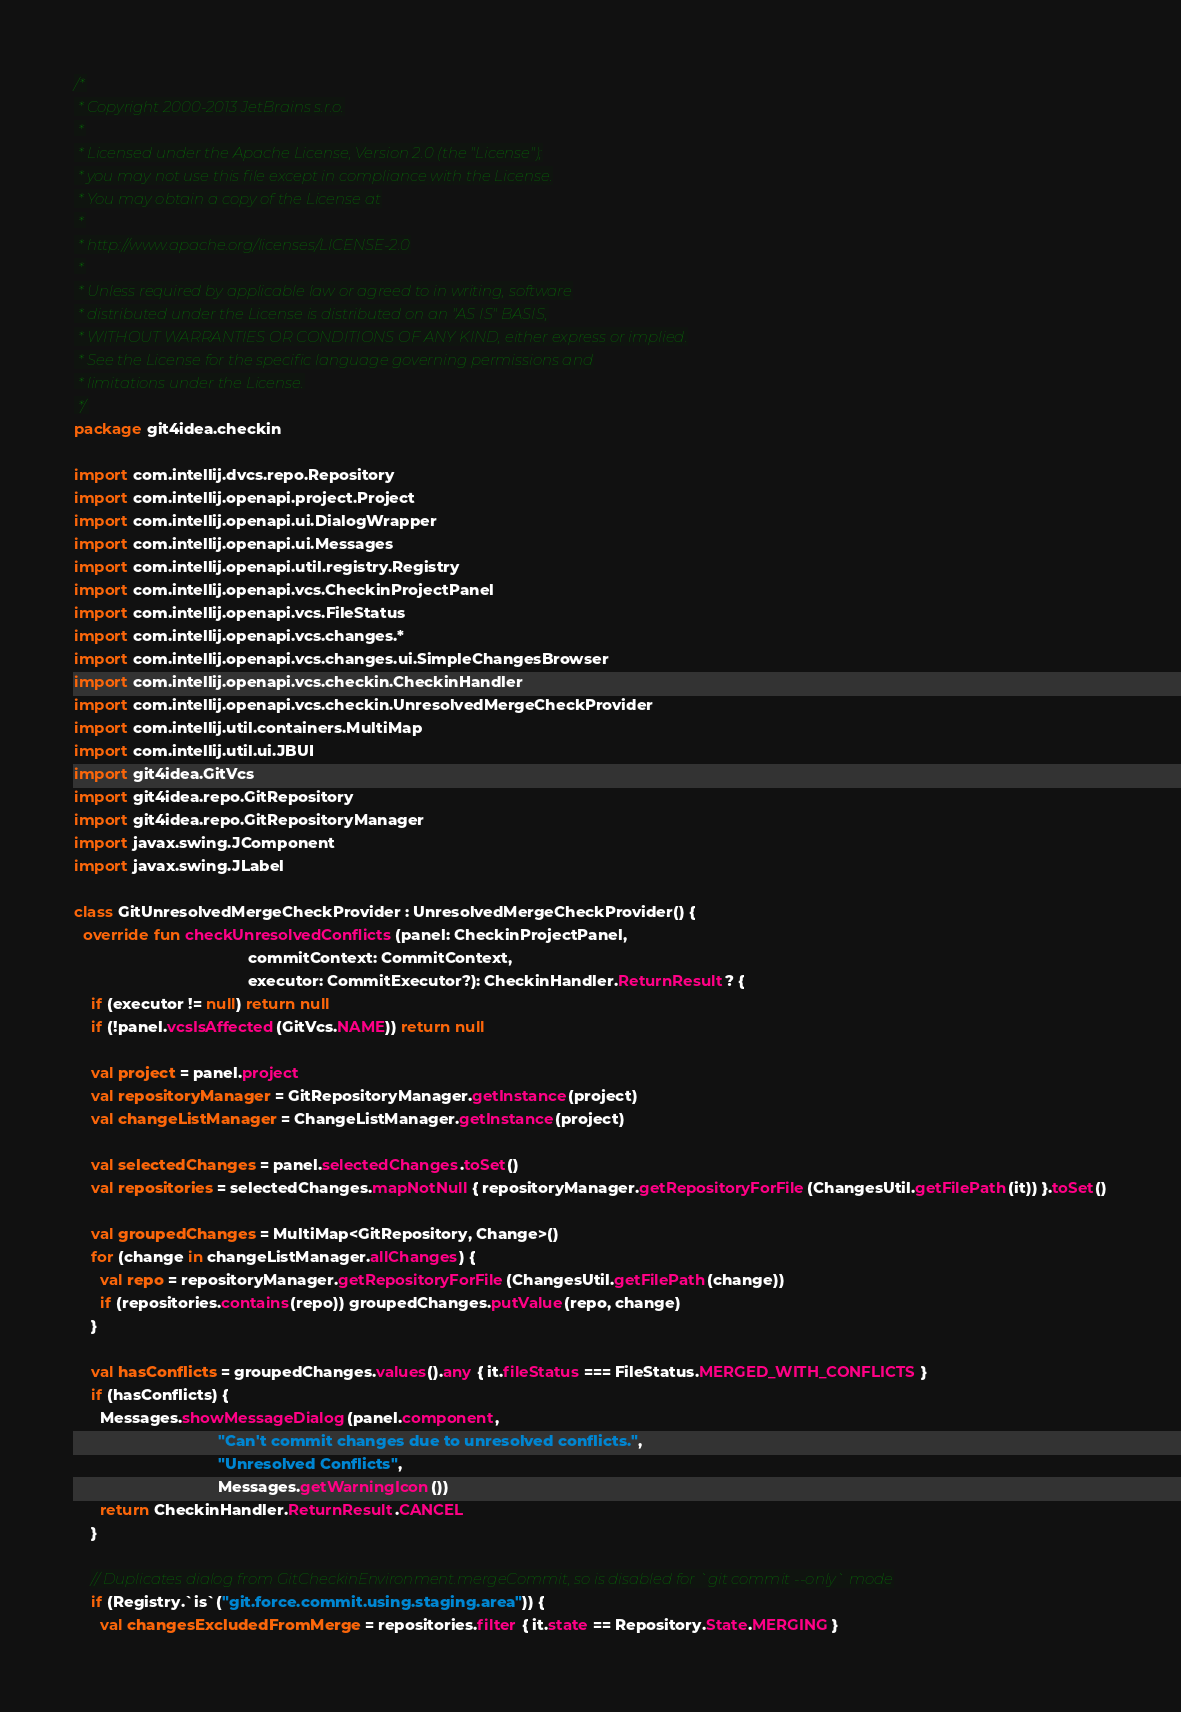Convert code to text. <code><loc_0><loc_0><loc_500><loc_500><_Kotlin_>/*
 * Copyright 2000-2013 JetBrains s.r.o.
 *
 * Licensed under the Apache License, Version 2.0 (the "License");
 * you may not use this file except in compliance with the License.
 * You may obtain a copy of the License at
 *
 * http://www.apache.org/licenses/LICENSE-2.0
 *
 * Unless required by applicable law or agreed to in writing, software
 * distributed under the License is distributed on an "AS IS" BASIS,
 * WITHOUT WARRANTIES OR CONDITIONS OF ANY KIND, either express or implied.
 * See the License for the specific language governing permissions and
 * limitations under the License.
 */
package git4idea.checkin

import com.intellij.dvcs.repo.Repository
import com.intellij.openapi.project.Project
import com.intellij.openapi.ui.DialogWrapper
import com.intellij.openapi.ui.Messages
import com.intellij.openapi.util.registry.Registry
import com.intellij.openapi.vcs.CheckinProjectPanel
import com.intellij.openapi.vcs.FileStatus
import com.intellij.openapi.vcs.changes.*
import com.intellij.openapi.vcs.changes.ui.SimpleChangesBrowser
import com.intellij.openapi.vcs.checkin.CheckinHandler
import com.intellij.openapi.vcs.checkin.UnresolvedMergeCheckProvider
import com.intellij.util.containers.MultiMap
import com.intellij.util.ui.JBUI
import git4idea.GitVcs
import git4idea.repo.GitRepository
import git4idea.repo.GitRepositoryManager
import javax.swing.JComponent
import javax.swing.JLabel

class GitUnresolvedMergeCheckProvider : UnresolvedMergeCheckProvider() {
  override fun checkUnresolvedConflicts(panel: CheckinProjectPanel,
                                        commitContext: CommitContext,
                                        executor: CommitExecutor?): CheckinHandler.ReturnResult? {
    if (executor != null) return null
    if (!panel.vcsIsAffected(GitVcs.NAME)) return null

    val project = panel.project
    val repositoryManager = GitRepositoryManager.getInstance(project)
    val changeListManager = ChangeListManager.getInstance(project)

    val selectedChanges = panel.selectedChanges.toSet()
    val repositories = selectedChanges.mapNotNull { repositoryManager.getRepositoryForFile(ChangesUtil.getFilePath(it)) }.toSet()

    val groupedChanges = MultiMap<GitRepository, Change>()
    for (change in changeListManager.allChanges) {
      val repo = repositoryManager.getRepositoryForFile(ChangesUtil.getFilePath(change))
      if (repositories.contains(repo)) groupedChanges.putValue(repo, change)
    }

    val hasConflicts = groupedChanges.values().any { it.fileStatus === FileStatus.MERGED_WITH_CONFLICTS }
    if (hasConflicts) {
      Messages.showMessageDialog(panel.component,
                                 "Can't commit changes due to unresolved conflicts.",
                                 "Unresolved Conflicts",
                                 Messages.getWarningIcon())
      return CheckinHandler.ReturnResult.CANCEL
    }

    // Duplicates dialog from GitCheckinEnvironment.mergeCommit, so is disabled for `git commit --only` mode
    if (Registry.`is`("git.force.commit.using.staging.area")) {
      val changesExcludedFromMerge = repositories.filter { it.state == Repository.State.MERGING }</code> 